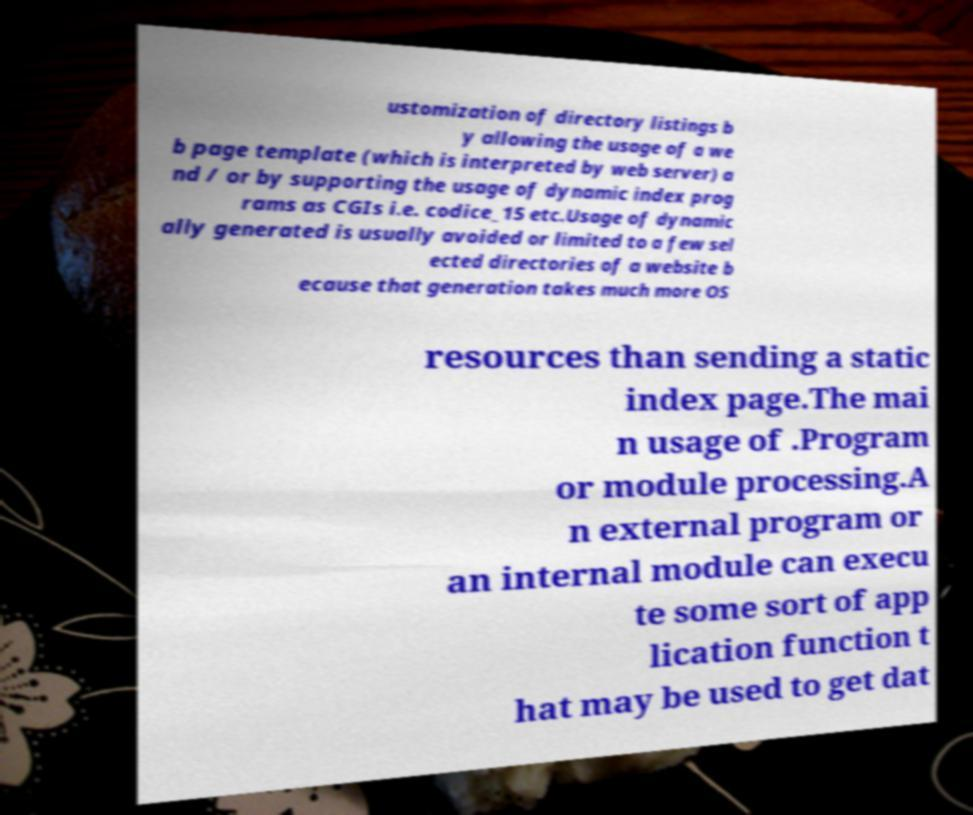For documentation purposes, I need the text within this image transcribed. Could you provide that? ustomization of directory listings b y allowing the usage of a we b page template (which is interpreted by web server) a nd / or by supporting the usage of dynamic index prog rams as CGIs i.e. codice_15 etc.Usage of dynamic ally generated is usually avoided or limited to a few sel ected directories of a website b ecause that generation takes much more OS resources than sending a static index page.The mai n usage of .Program or module processing.A n external program or an internal module can execu te some sort of app lication function t hat may be used to get dat 